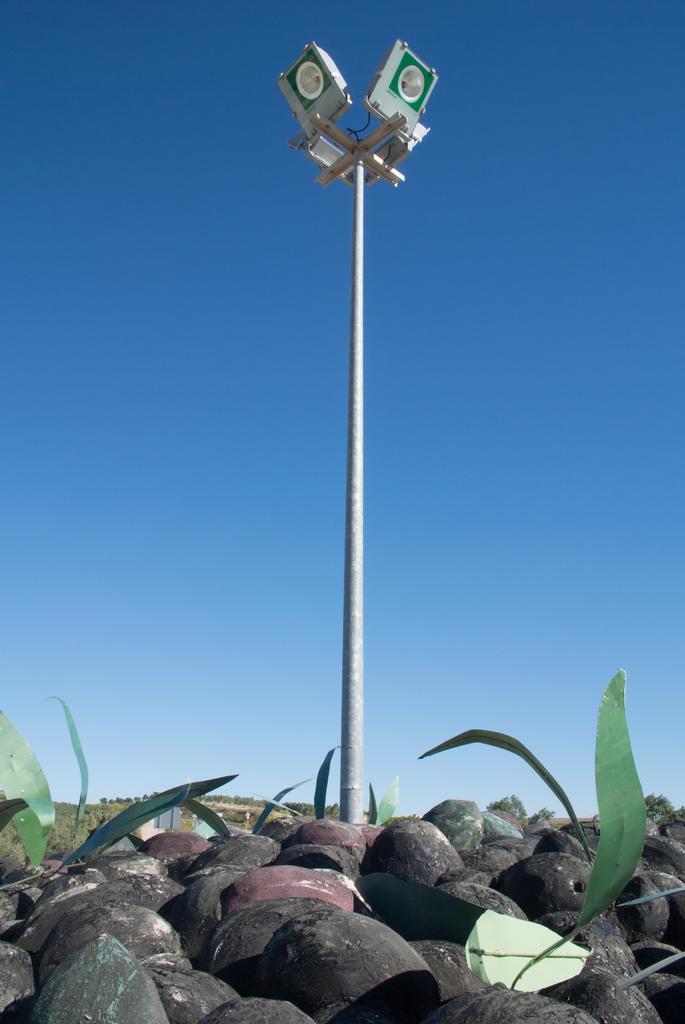Describe this image in one or two sentences. In the center of the image a pole, lights are there. At the top of the image sky is there. At the bottom of the image we can see rocks, trees, grass are present. 